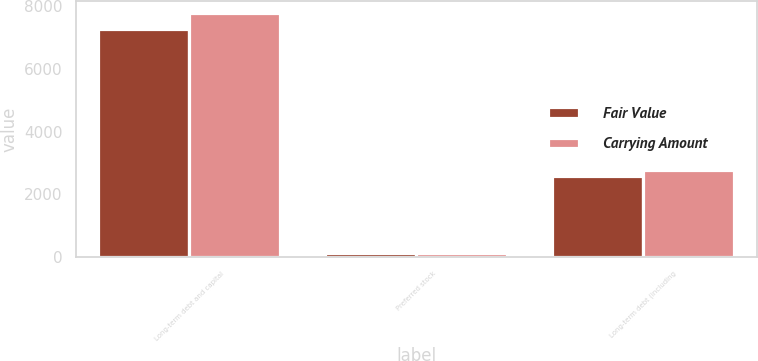Convert chart to OTSL. <chart><loc_0><loc_0><loc_500><loc_500><stacked_bar_chart><ecel><fcel>Long-term debt and capital<fcel>Preferred stock<fcel>Long-term debt (including<nl><fcel>Fair Value<fcel>7276<fcel>142<fcel>2588<nl><fcel>Carrying Amount<fcel>7772<fcel>131<fcel>2765<nl></chart> 